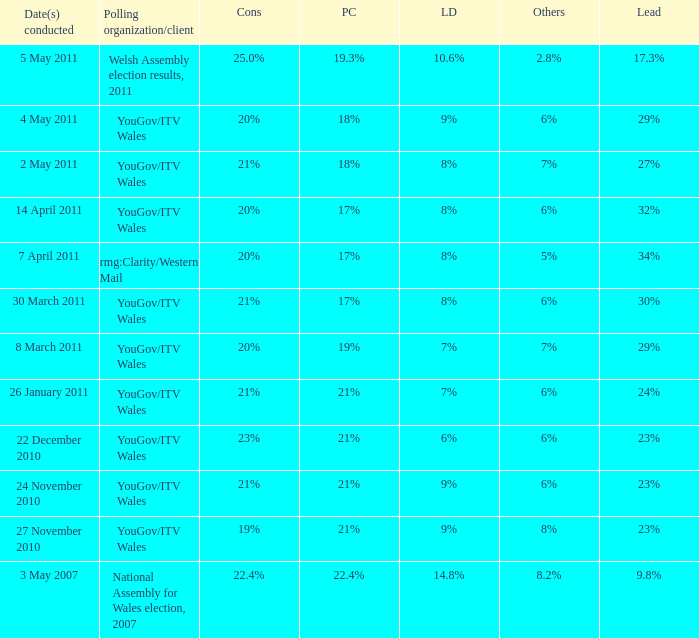Give me the full table as a dictionary. {'header': ['Date(s) conducted', 'Polling organization/client', 'Cons', 'PC', 'LD', 'Others', 'Lead'], 'rows': [['5 May 2011', 'Welsh Assembly election results, 2011', '25.0%', '19.3%', '10.6%', '2.8%', '17.3%'], ['4 May 2011', 'YouGov/ITV Wales', '20%', '18%', '9%', '6%', '29%'], ['2 May 2011', 'YouGov/ITV Wales', '21%', '18%', '8%', '7%', '27%'], ['14 April 2011', 'YouGov/ITV Wales', '20%', '17%', '8%', '6%', '32%'], ['7 April 2011', 'rmg:Clarity/Western Mail', '20%', '17%', '8%', '5%', '34%'], ['30 March 2011', 'YouGov/ITV Wales', '21%', '17%', '8%', '6%', '30%'], ['8 March 2011', 'YouGov/ITV Wales', '20%', '19%', '7%', '7%', '29%'], ['26 January 2011', 'YouGov/ITV Wales', '21%', '21%', '7%', '6%', '24%'], ['22 December 2010', 'YouGov/ITV Wales', '23%', '21%', '6%', '6%', '23%'], ['24 November 2010', 'YouGov/ITV Wales', '21%', '21%', '9%', '6%', '23%'], ['27 November 2010', 'YouGov/ITV Wales', '19%', '21%', '9%', '8%', '23%'], ['3 May 2007', 'National Assembly for Wales election, 2007', '22.4%', '22.4%', '14.8%', '8.2%', '9.8%']]} I want the lead for others being 5% 34%. 